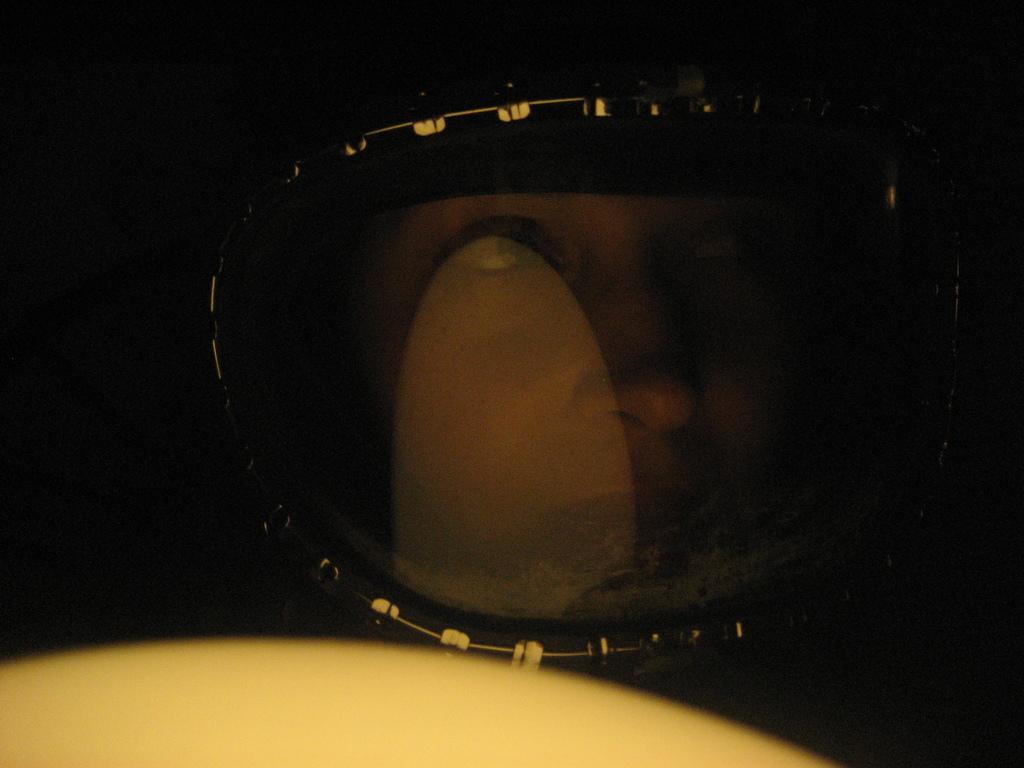In one or two sentences, can you explain what this image depicts? In this image at front there is a person wearing the helmet. 